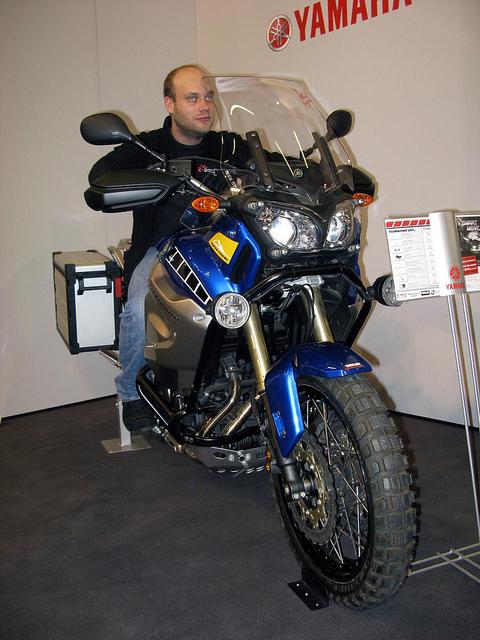Is the motorcycle screwed to the floor?
Give a very brief answer. Yes. Is he going for a ride?
Short answer required. No. What color is the sign on the wall?
Give a very brief answer. Red. Does the man have all his hair?
Quick response, please. No. What is cast?
Short answer required. Motorcycle. 